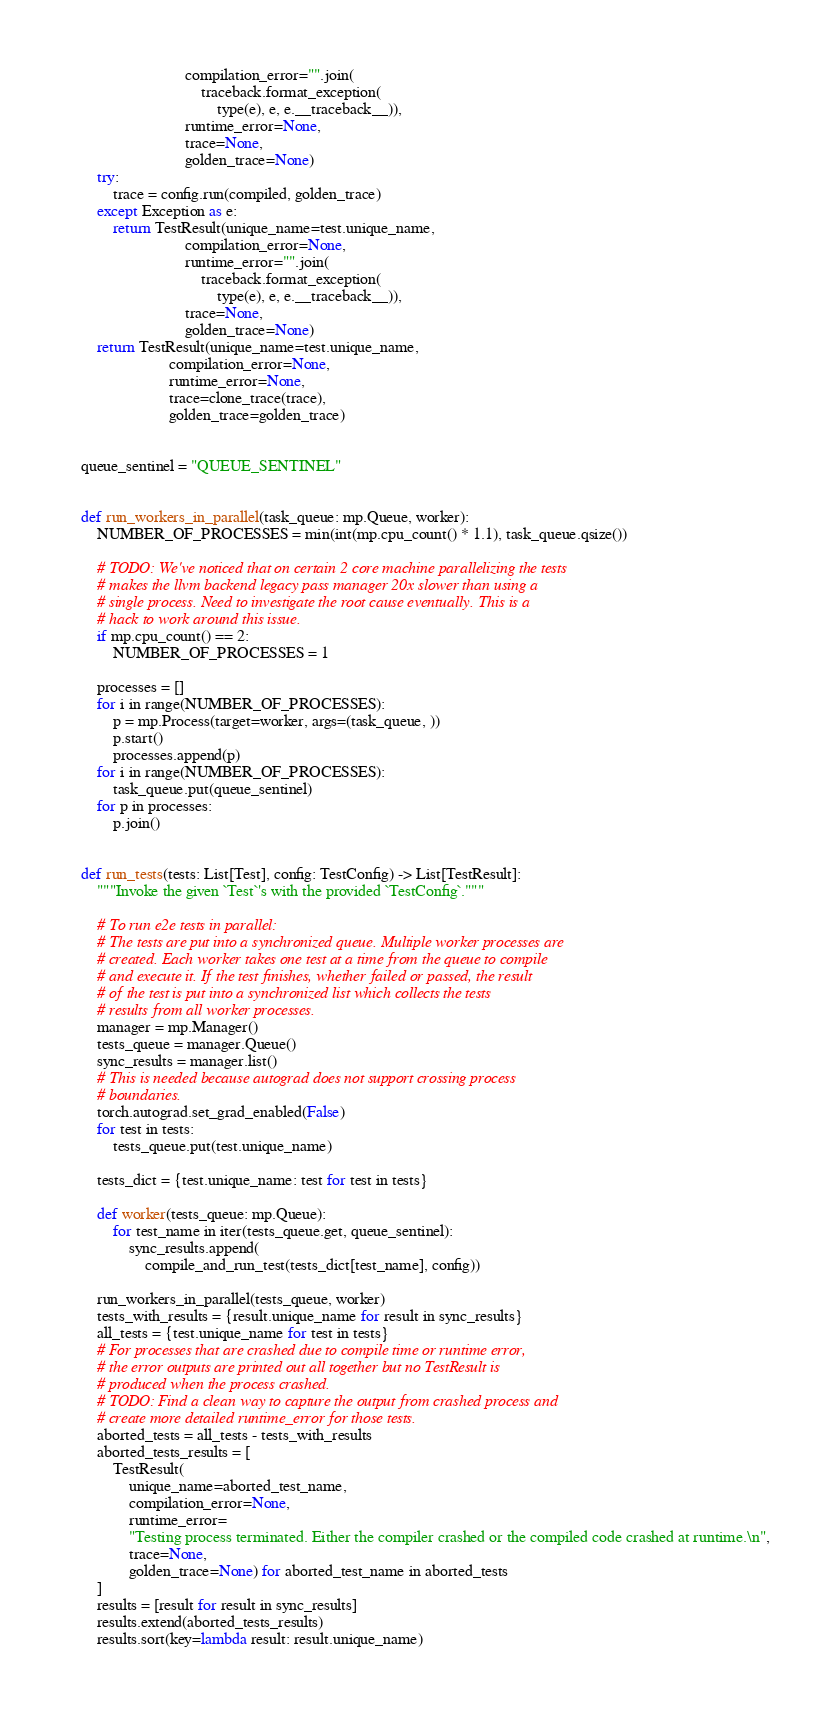Convert code to text. <code><loc_0><loc_0><loc_500><loc_500><_Python_>                          compilation_error="".join(
                              traceback.format_exception(
                                  type(e), e, e.__traceback__)),
                          runtime_error=None,
                          trace=None,
                          golden_trace=None)
    try:
        trace = config.run(compiled, golden_trace)
    except Exception as e:
        return TestResult(unique_name=test.unique_name,
                          compilation_error=None,
                          runtime_error="".join(
                              traceback.format_exception(
                                  type(e), e, e.__traceback__)),
                          trace=None,
                          golden_trace=None)
    return TestResult(unique_name=test.unique_name,
                      compilation_error=None,
                      runtime_error=None,
                      trace=clone_trace(trace),
                      golden_trace=golden_trace)


queue_sentinel = "QUEUE_SENTINEL"


def run_workers_in_parallel(task_queue: mp.Queue, worker):
    NUMBER_OF_PROCESSES = min(int(mp.cpu_count() * 1.1), task_queue.qsize())

    # TODO: We've noticed that on certain 2 core machine parallelizing the tests
    # makes the llvm backend legacy pass manager 20x slower than using a
    # single process. Need to investigate the root cause eventually. This is a
    # hack to work around this issue.
    if mp.cpu_count() == 2:
        NUMBER_OF_PROCESSES = 1

    processes = []
    for i in range(NUMBER_OF_PROCESSES):
        p = mp.Process(target=worker, args=(task_queue, ))
        p.start()
        processes.append(p)
    for i in range(NUMBER_OF_PROCESSES):
        task_queue.put(queue_sentinel)
    for p in processes:
        p.join()


def run_tests(tests: List[Test], config: TestConfig) -> List[TestResult]:
    """Invoke the given `Test`'s with the provided `TestConfig`."""

    # To run e2e tests in parallel:
    # The tests are put into a synchronized queue. Multiple worker processes are
    # created. Each worker takes one test at a time from the queue to compile
    # and execute it. If the test finishes, whether failed or passed, the result
    # of the test is put into a synchronized list which collects the tests
    # results from all worker processes.
    manager = mp.Manager()
    tests_queue = manager.Queue()
    sync_results = manager.list()
    # This is needed because autograd does not support crossing process
    # boundaries.
    torch.autograd.set_grad_enabled(False)
    for test in tests:
        tests_queue.put(test.unique_name)

    tests_dict = {test.unique_name: test for test in tests}

    def worker(tests_queue: mp.Queue):
        for test_name in iter(tests_queue.get, queue_sentinel):
            sync_results.append(
                compile_and_run_test(tests_dict[test_name], config))

    run_workers_in_parallel(tests_queue, worker)
    tests_with_results = {result.unique_name for result in sync_results}
    all_tests = {test.unique_name for test in tests}
    # For processes that are crashed due to compile time or runtime error,
    # the error outputs are printed out all together but no TestResult is
    # produced when the process crashed.
    # TODO: Find a clean way to capture the output from crashed process and
    # create more detailed runtime_error for those tests.
    aborted_tests = all_tests - tests_with_results
    aborted_tests_results = [
        TestResult(
            unique_name=aborted_test_name,
            compilation_error=None,
            runtime_error=
            "Testing process terminated. Either the compiler crashed or the compiled code crashed at runtime.\n",
            trace=None,
            golden_trace=None) for aborted_test_name in aborted_tests
    ]
    results = [result for result in sync_results]
    results.extend(aborted_tests_results)
    results.sort(key=lambda result: result.unique_name)</code> 